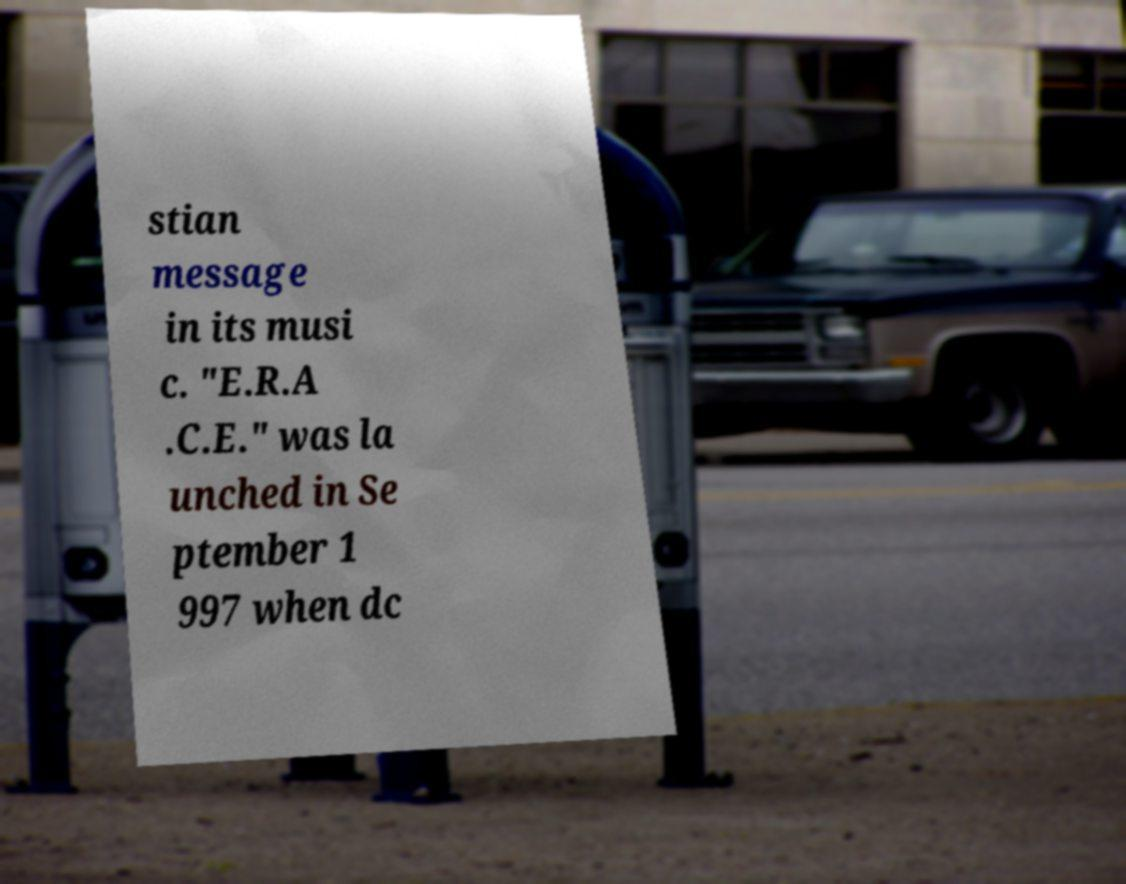I need the written content from this picture converted into text. Can you do that? stian message in its musi c. "E.R.A .C.E." was la unched in Se ptember 1 997 when dc 